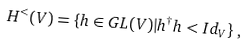<formula> <loc_0><loc_0><loc_500><loc_500>H ^ { < } ( V ) = \{ h \in G L ( V ) | h ^ { \dagger } h < I d _ { V } \} \, ,</formula> 